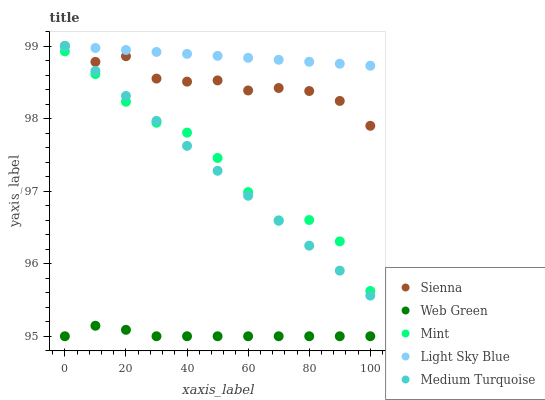Does Web Green have the minimum area under the curve?
Answer yes or no. Yes. Does Light Sky Blue have the maximum area under the curve?
Answer yes or no. Yes. Does Mint have the minimum area under the curve?
Answer yes or no. No. Does Mint have the maximum area under the curve?
Answer yes or no. No. Is Medium Turquoise the smoothest?
Answer yes or no. Yes. Is Mint the roughest?
Answer yes or no. Yes. Is Light Sky Blue the smoothest?
Answer yes or no. No. Is Light Sky Blue the roughest?
Answer yes or no. No. Does Web Green have the lowest value?
Answer yes or no. Yes. Does Mint have the lowest value?
Answer yes or no. No. Does Medium Turquoise have the highest value?
Answer yes or no. Yes. Does Mint have the highest value?
Answer yes or no. No. Is Mint less than Sienna?
Answer yes or no. Yes. Is Light Sky Blue greater than Web Green?
Answer yes or no. Yes. Does Medium Turquoise intersect Light Sky Blue?
Answer yes or no. Yes. Is Medium Turquoise less than Light Sky Blue?
Answer yes or no. No. Is Medium Turquoise greater than Light Sky Blue?
Answer yes or no. No. Does Mint intersect Sienna?
Answer yes or no. No. 